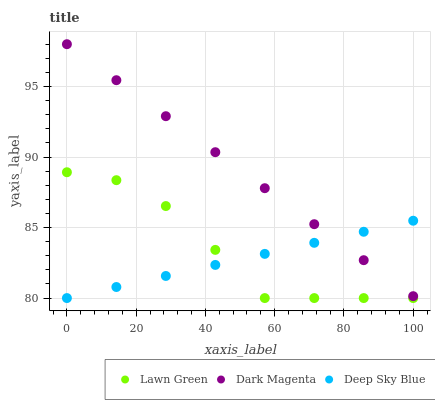Does Deep Sky Blue have the minimum area under the curve?
Answer yes or no. Yes. Does Dark Magenta have the maximum area under the curve?
Answer yes or no. Yes. Does Dark Magenta have the minimum area under the curve?
Answer yes or no. No. Does Deep Sky Blue have the maximum area under the curve?
Answer yes or no. No. Is Deep Sky Blue the smoothest?
Answer yes or no. Yes. Is Lawn Green the roughest?
Answer yes or no. Yes. Is Dark Magenta the smoothest?
Answer yes or no. No. Is Dark Magenta the roughest?
Answer yes or no. No. Does Lawn Green have the lowest value?
Answer yes or no. Yes. Does Dark Magenta have the lowest value?
Answer yes or no. No. Does Dark Magenta have the highest value?
Answer yes or no. Yes. Does Deep Sky Blue have the highest value?
Answer yes or no. No. Is Lawn Green less than Dark Magenta?
Answer yes or no. Yes. Is Dark Magenta greater than Lawn Green?
Answer yes or no. Yes. Does Lawn Green intersect Deep Sky Blue?
Answer yes or no. Yes. Is Lawn Green less than Deep Sky Blue?
Answer yes or no. No. Is Lawn Green greater than Deep Sky Blue?
Answer yes or no. No. Does Lawn Green intersect Dark Magenta?
Answer yes or no. No. 